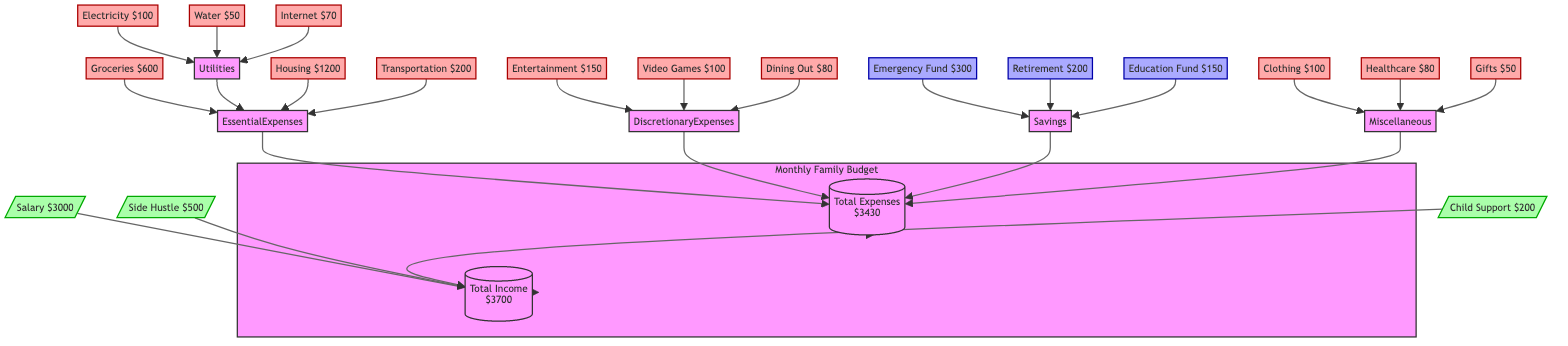What is the total income shown in the diagram? The total income is the sum of Salary, Side Hustle, and Child Support. Adding them together: 3000 + 500 + 200 equals 3700.
Answer: 3700 What are the essential expenses related to utilities? The essential expenses for utilities include Electricity, Water, and Internet. The corresponding amounts are 100, 50, and 70 respectively, which are all grouped under Utilities.
Answer: Electricity, Water, Internet How much is allocated for video games in discretionary expenses? The diagram shows that Video Games is listed as a discretionary expense with a value of 100. This is directly stated under Discretionary Expenses.
Answer: 100 What is the total for miscellaneous expenses? The total for miscellaneous expenses includes Clothing, Healthcare, and Gifts, which are valued at 100, 80, and 50. Adding these amounts together gives: 100 + 80 + 50 equals 230.
Answer: 230 What is the emergency fund amount? The emergency fund amount is specifically indicated in the Savings section, showing a value of 300. This is a direct representation from the diagram.
Answer: 300 What is the relationship between total expenses and savings? Total Expenses is a parent node that encompasses essential expenses, discretionary expenses, savings, and miscellaneous expenses. This indicates that savings contribute to the overall total expenses in the budgeting process.
Answer: Total Expenses includes Savings How much is spent on dining out? The expense for dining out is explicitly mentioned in the Discretionary Expenses section, noted as 80. This is a clear figure presented in the diagram.
Answer: 80 How much remains after subtracting total expenses from the total income? The remaining amount is calculated by subtracting Total Expenses (3430) from Total Income (3700). So, 3700 - 3430 equals 270.
Answer: 270 What percentage of total income is allocated to essential expenses? To find the percentage, first, calculate the total of essential expenses, which is 600 + (100 + 50 + 70) + 1200 + 200 equals 2220. Then, calculate the percentage: (2220 / 3700) * 100 equals approximately 60%.
Answer: 60% 